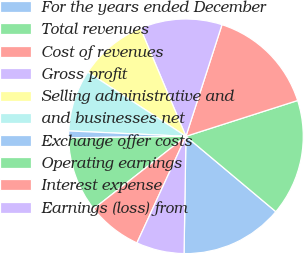<chart> <loc_0><loc_0><loc_500><loc_500><pie_chart><fcel>For the years ended December<fcel>Total revenues<fcel>Cost of revenues<fcel>Gross profit<fcel>Selling administrative and<fcel>and businesses net<fcel>Exchange offer costs<fcel>Operating earnings<fcel>Interest expense<fcel>Earnings (loss) from<nl><fcel>14.15%<fcel>16.04%<fcel>15.09%<fcel>11.32%<fcel>9.43%<fcel>8.49%<fcel>0.94%<fcel>10.38%<fcel>7.55%<fcel>6.6%<nl></chart> 